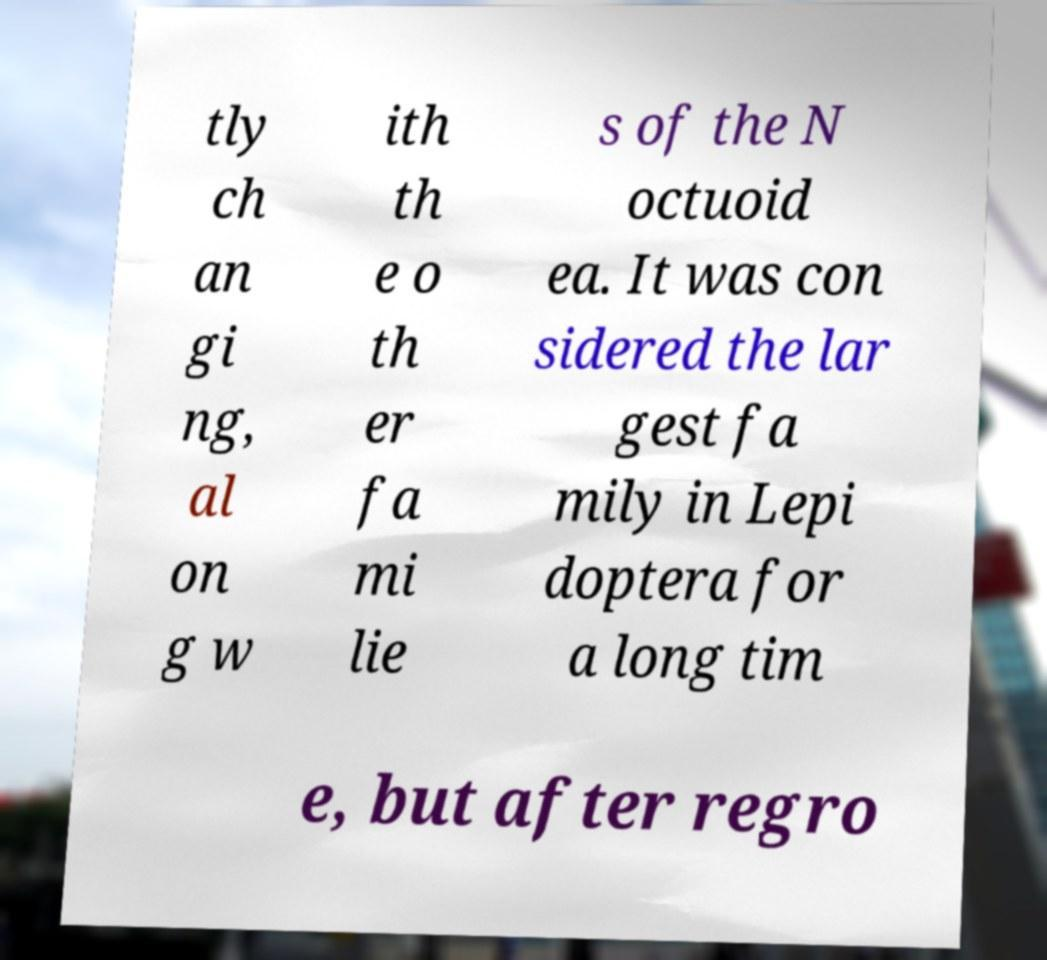For documentation purposes, I need the text within this image transcribed. Could you provide that? tly ch an gi ng, al on g w ith th e o th er fa mi lie s of the N octuoid ea. It was con sidered the lar gest fa mily in Lepi doptera for a long tim e, but after regro 